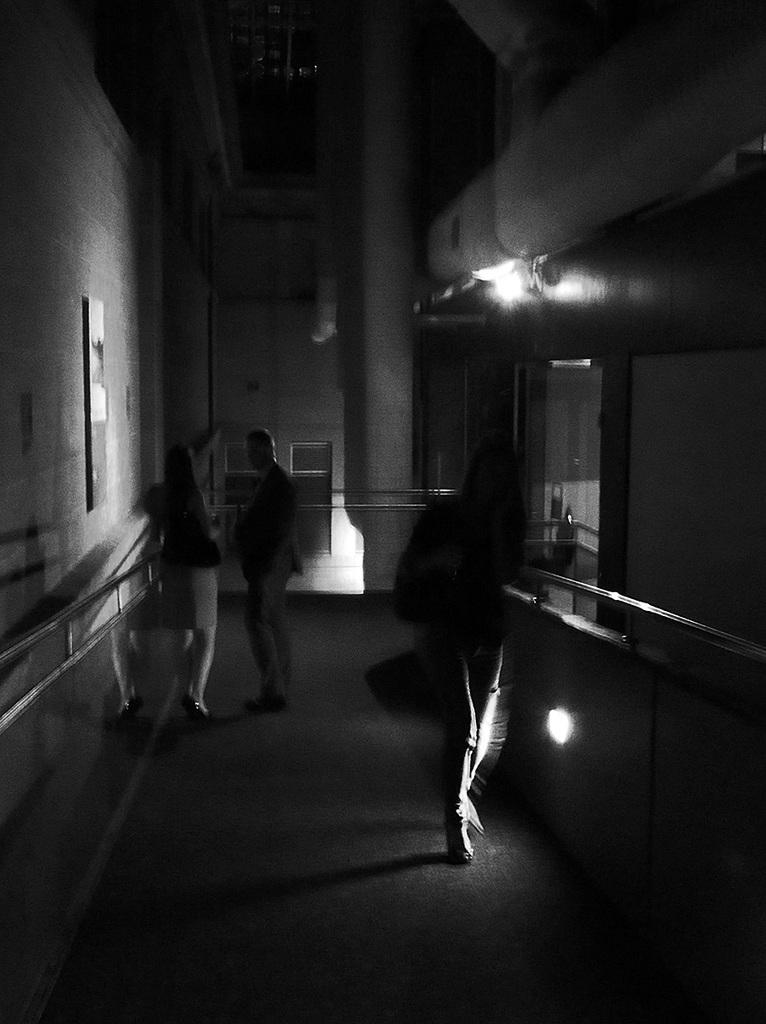What are the people in the image doing? The persons in the image are standing on the stair of the building. What can be seen attached to the wall in the image? There is a frame attached to the wall. What part of the building is visible in the image? The roof is visible in the image. How many chances does the dog have to climb the stairs in the image? There is no dog present in the image, so the question cannot be answered. 